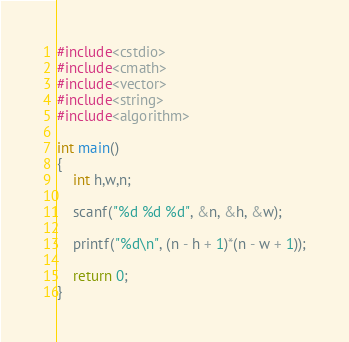<code> <loc_0><loc_0><loc_500><loc_500><_C++_>#include<cstdio>
#include<cmath>
#include<vector>
#include<string>
#include<algorithm>

int main()
{
	int h,w,n;

	scanf("%d %d %d", &n, &h, &w);

	printf("%d\n", (n - h + 1)*(n - w + 1));

	return 0;
}	</code> 